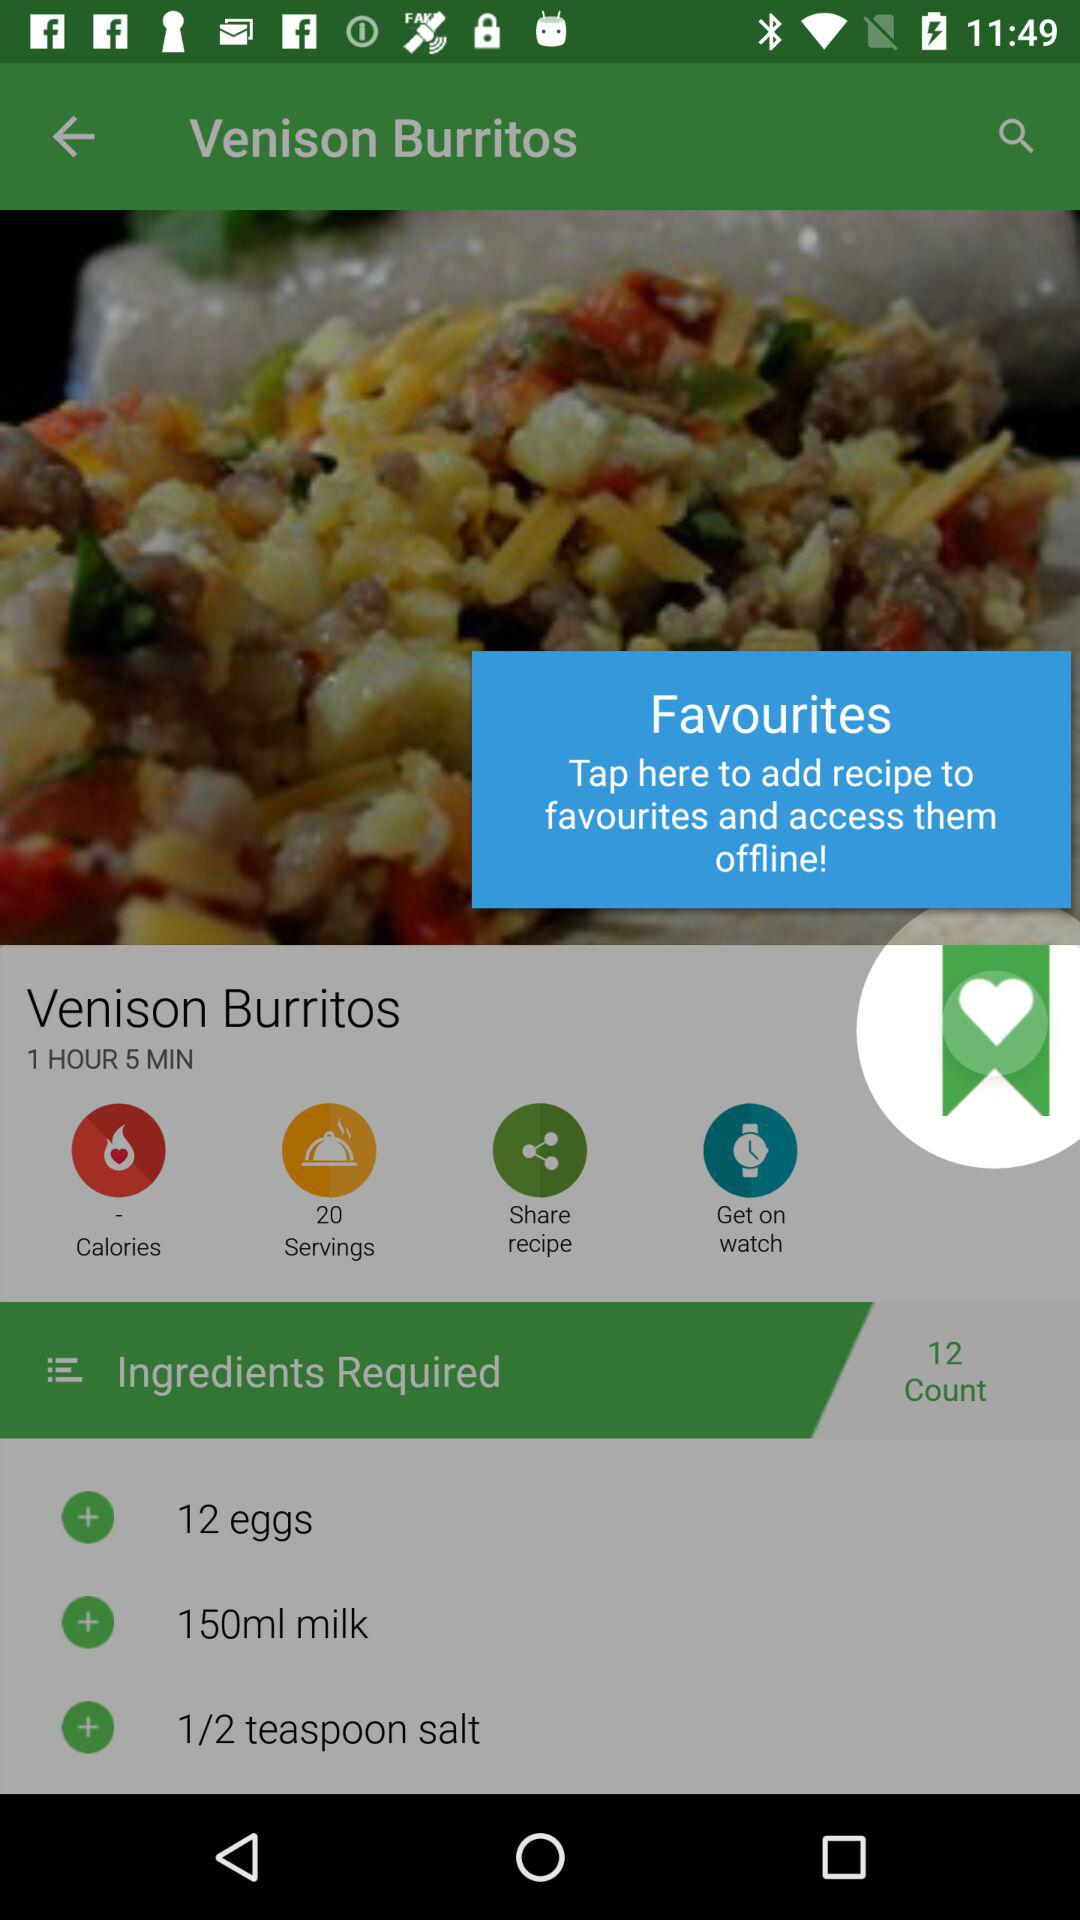How many eggs are required for the dish? The number of eggs required for the dish is 12. 